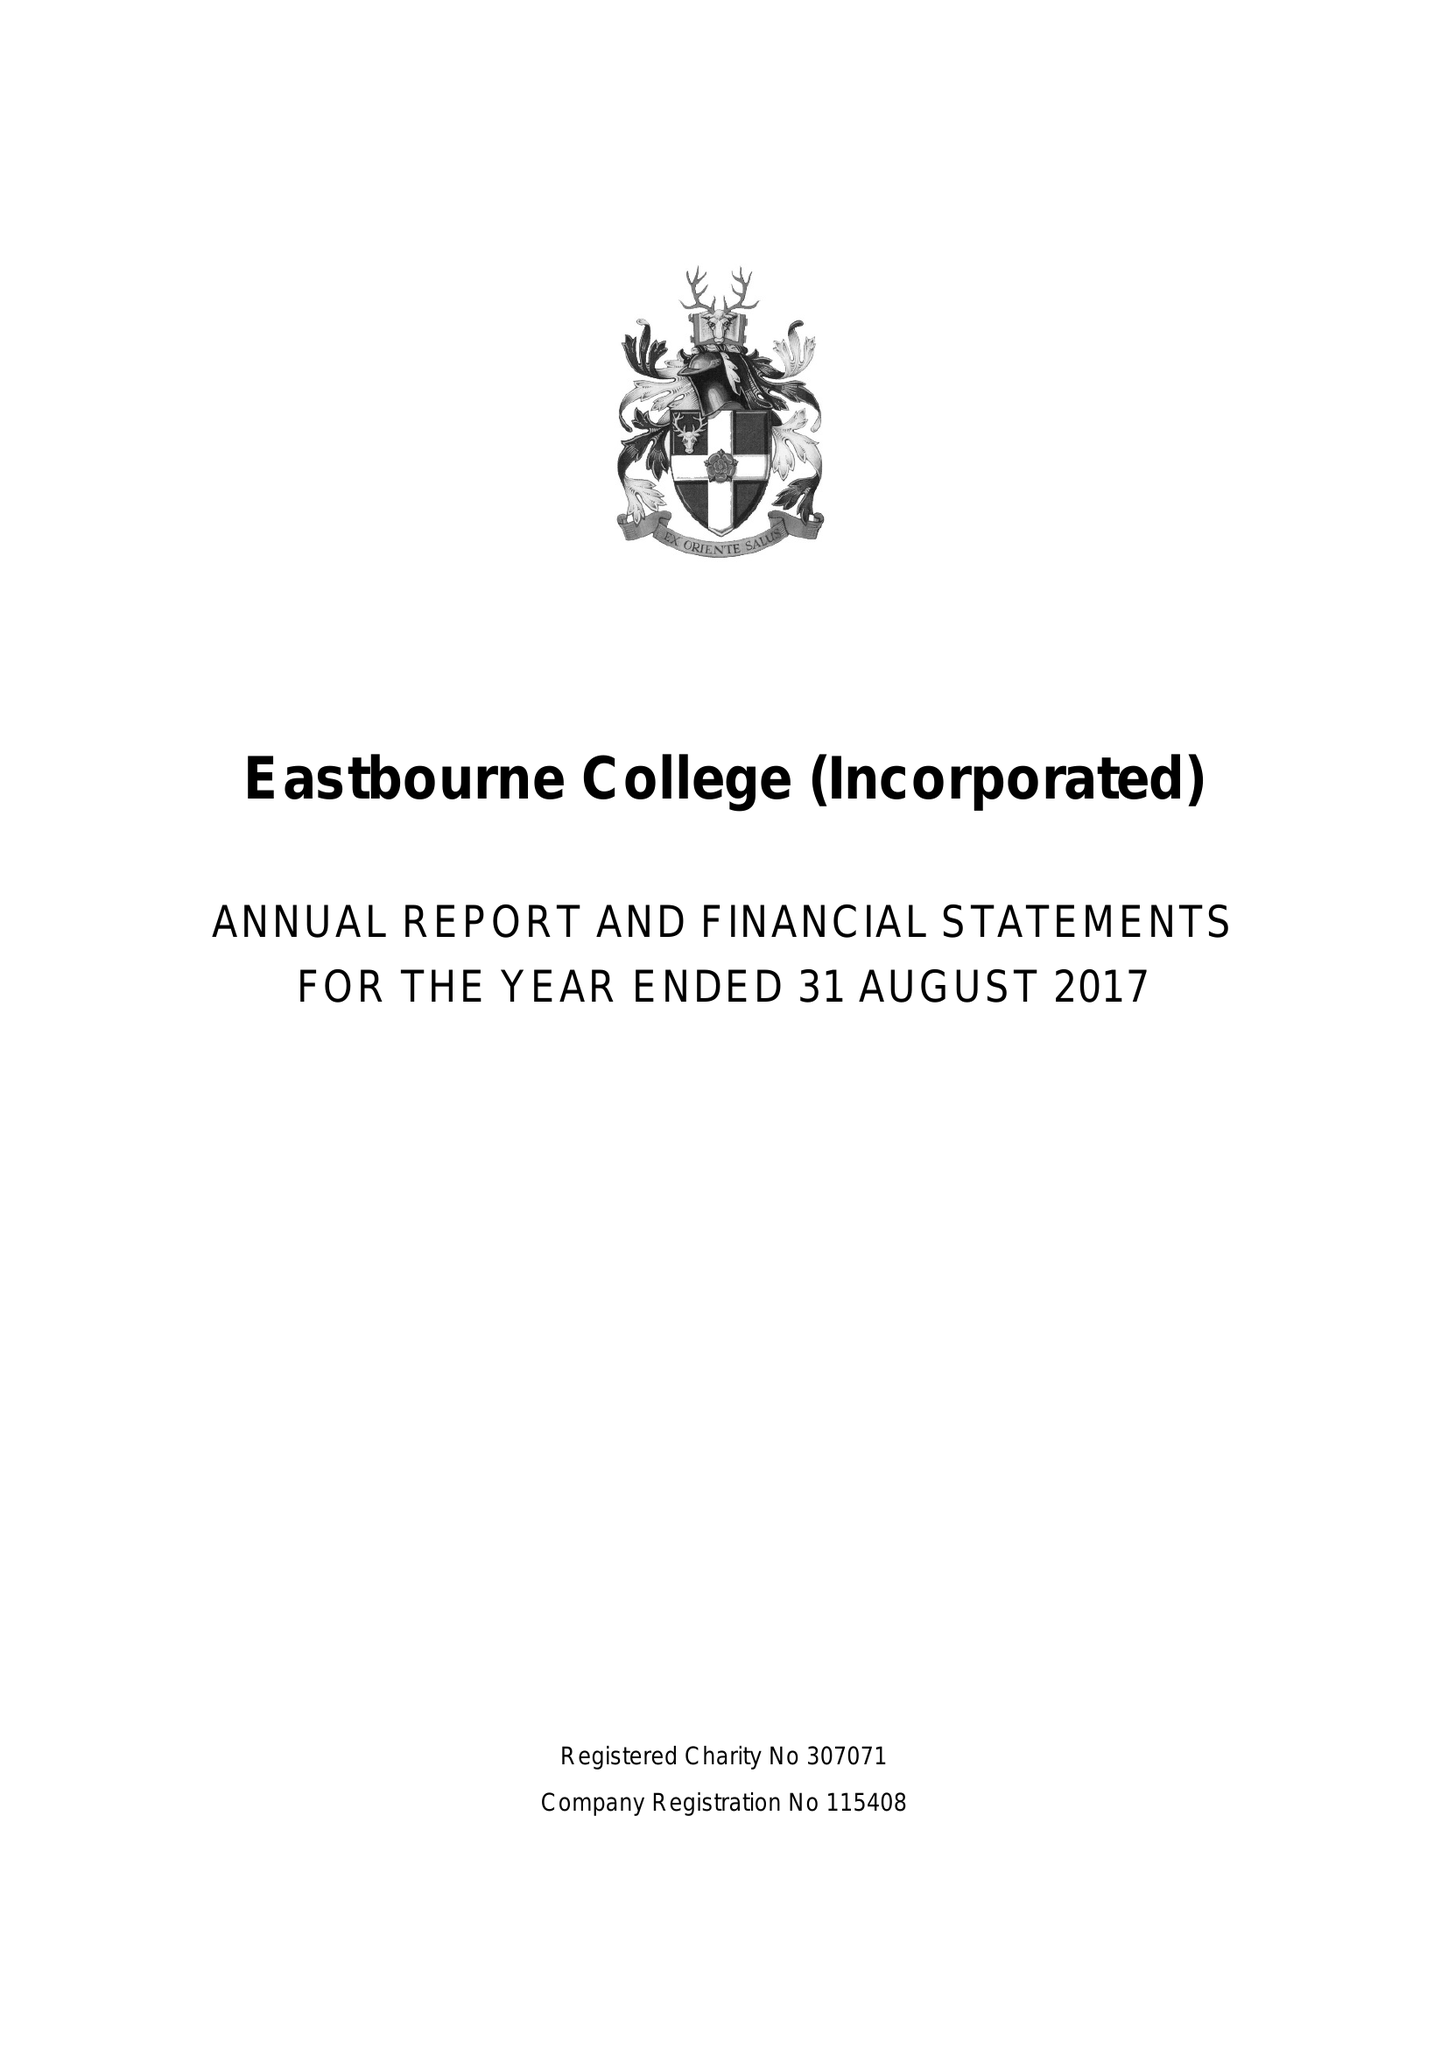What is the value for the report_date?
Answer the question using a single word or phrase. 2017-08-31 